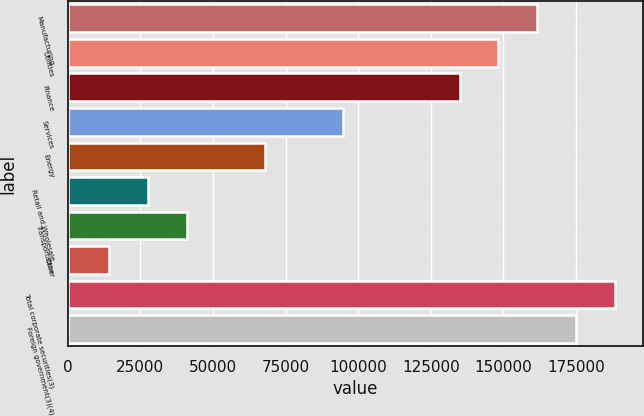<chart> <loc_0><loc_0><loc_500><loc_500><bar_chart><fcel>Manufacturing<fcel>Utilities<fcel>Finance<fcel>Services<fcel>Energy<fcel>Retail and Wholesale<fcel>Transportation<fcel>Other<fcel>Total corporate securities(3)<fcel>Foreign government(3)(4)<nl><fcel>161711<fcel>148301<fcel>134892<fcel>94664.1<fcel>67845.5<fcel>27617.6<fcel>41026.9<fcel>14208.3<fcel>188529<fcel>175120<nl></chart> 